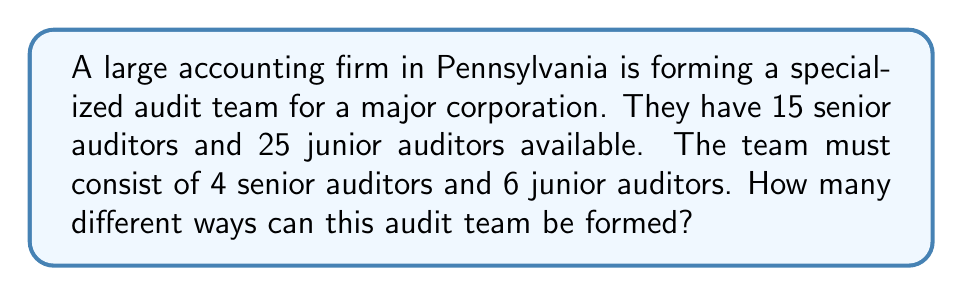Teach me how to tackle this problem. Let's approach this step-by-step:

1) We need to select 4 senior auditors out of 15, and 6 junior auditors out of 25.

2) For the senior auditors:
   - This is a combination problem, as the order doesn't matter.
   - We use the formula: $C(n,r) = \frac{n!}{r!(n-r)!}$
   - Here, $n = 15$ and $r = 4$
   - So, we have: $C(15,4) = \frac{15!}{4!(15-4)!} = \frac{15!}{4!11!}$

3) For the junior auditors:
   - Similarly, we use the combination formula
   - Here, $n = 25$ and $r = 6$
   - So, we have: $C(25,6) = \frac{25!}{6!(25-6)!} = \frac{25!}{6!19!}$

4) By the Multiplication Principle, the total number of ways to form the team is:
   $$C(15,4) \times C(25,6)$$

5) Let's calculate:
   $$C(15,4) = \frac{15!}{4!11!} = 1365$$
   $$C(25,6) = \frac{25!}{6!19!} = 177100$$

6) Therefore, the total number of ways is:
   $$1365 \times 177100 = 241,741,500$$
Answer: 241,741,500 ways 